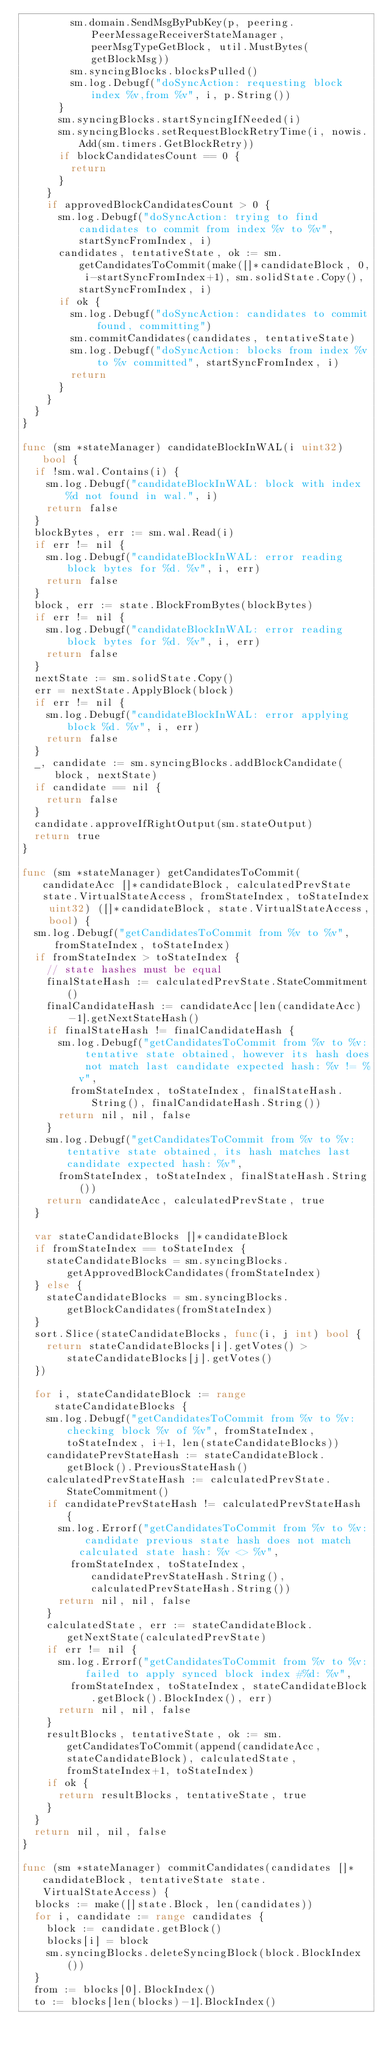<code> <loc_0><loc_0><loc_500><loc_500><_Go_>				sm.domain.SendMsgByPubKey(p, peering.PeerMessageReceiverStateManager, peerMsgTypeGetBlock, util.MustBytes(getBlockMsg))
				sm.syncingBlocks.blocksPulled()
				sm.log.Debugf("doSyncAction: requesting block index %v,from %v", i, p.String())
			}
			sm.syncingBlocks.startSyncingIfNeeded(i)
			sm.syncingBlocks.setRequestBlockRetryTime(i, nowis.Add(sm.timers.GetBlockRetry))
			if blockCandidatesCount == 0 {
				return
			}
		}
		if approvedBlockCandidatesCount > 0 {
			sm.log.Debugf("doSyncAction: trying to find candidates to commit from index %v to %v", startSyncFromIndex, i)
			candidates, tentativeState, ok := sm.getCandidatesToCommit(make([]*candidateBlock, 0, i-startSyncFromIndex+1), sm.solidState.Copy(), startSyncFromIndex, i)
			if ok {
				sm.log.Debugf("doSyncAction: candidates to commit found, committing")
				sm.commitCandidates(candidates, tentativeState)
				sm.log.Debugf("doSyncAction: blocks from index %v to %v committed", startSyncFromIndex, i)
				return
			}
		}
	}
}

func (sm *stateManager) candidateBlockInWAL(i uint32) bool {
	if !sm.wal.Contains(i) {
		sm.log.Debugf("candidateBlockInWAL: block with index %d not found in wal.", i)
		return false
	}
	blockBytes, err := sm.wal.Read(i)
	if err != nil {
		sm.log.Debugf("candidateBlockInWAL: error reading block bytes for %d. %v", i, err)
		return false
	}
	block, err := state.BlockFromBytes(blockBytes)
	if err != nil {
		sm.log.Debugf("candidateBlockInWAL: error reading block bytes for %d. %v", i, err)
		return false
	}
	nextState := sm.solidState.Copy()
	err = nextState.ApplyBlock(block)
	if err != nil {
		sm.log.Debugf("candidateBlockInWAL: error applying block %d. %v", i, err)
		return false
	}
	_, candidate := sm.syncingBlocks.addBlockCandidate(block, nextState)
	if candidate == nil {
		return false
	}
	candidate.approveIfRightOutput(sm.stateOutput)
	return true
}

func (sm *stateManager) getCandidatesToCommit(candidateAcc []*candidateBlock, calculatedPrevState state.VirtualStateAccess, fromStateIndex, toStateIndex uint32) ([]*candidateBlock, state.VirtualStateAccess, bool) {
	sm.log.Debugf("getCandidatesToCommit from %v to %v", fromStateIndex, toStateIndex)
	if fromStateIndex > toStateIndex {
		// state hashes must be equal
		finalStateHash := calculatedPrevState.StateCommitment()
		finalCandidateHash := candidateAcc[len(candidateAcc)-1].getNextStateHash()
		if finalStateHash != finalCandidateHash {
			sm.log.Debugf("getCandidatesToCommit from %v to %v: tentative state obtained, however its hash does not match last candidate expected hash: %v != %v",
				fromStateIndex, toStateIndex, finalStateHash.String(), finalCandidateHash.String())
			return nil, nil, false
		}
		sm.log.Debugf("getCandidatesToCommit from %v to %v: tentative state obtained, its hash matches last candidate expected hash: %v",
			fromStateIndex, toStateIndex, finalStateHash.String())
		return candidateAcc, calculatedPrevState, true
	}

	var stateCandidateBlocks []*candidateBlock
	if fromStateIndex == toStateIndex {
		stateCandidateBlocks = sm.syncingBlocks.getApprovedBlockCandidates(fromStateIndex)
	} else {
		stateCandidateBlocks = sm.syncingBlocks.getBlockCandidates(fromStateIndex)
	}
	sort.Slice(stateCandidateBlocks, func(i, j int) bool {
		return stateCandidateBlocks[i].getVotes() > stateCandidateBlocks[j].getVotes()
	})

	for i, stateCandidateBlock := range stateCandidateBlocks {
		sm.log.Debugf("getCandidatesToCommit from %v to %v: checking block %v of %v", fromStateIndex, toStateIndex, i+1, len(stateCandidateBlocks))
		candidatePrevStateHash := stateCandidateBlock.getBlock().PreviousStateHash()
		calculatedPrevStateHash := calculatedPrevState.StateCommitment()
		if candidatePrevStateHash != calculatedPrevStateHash {
			sm.log.Errorf("getCandidatesToCommit from %v to %v: candidate previous state hash does not match calculated state hash: %v <> %v",
				fromStateIndex, toStateIndex, candidatePrevStateHash.String(), calculatedPrevStateHash.String())
			return nil, nil, false
		}
		calculatedState, err := stateCandidateBlock.getNextState(calculatedPrevState)
		if err != nil {
			sm.log.Errorf("getCandidatesToCommit from %v to %v: failed to apply synced block index #%d: %v",
				fromStateIndex, toStateIndex, stateCandidateBlock.getBlock().BlockIndex(), err)
			return nil, nil, false
		}
		resultBlocks, tentativeState, ok := sm.getCandidatesToCommit(append(candidateAcc, stateCandidateBlock), calculatedState, fromStateIndex+1, toStateIndex)
		if ok {
			return resultBlocks, tentativeState, true
		}
	}
	return nil, nil, false
}

func (sm *stateManager) commitCandidates(candidates []*candidateBlock, tentativeState state.VirtualStateAccess) {
	blocks := make([]state.Block, len(candidates))
	for i, candidate := range candidates {
		block := candidate.getBlock()
		blocks[i] = block
		sm.syncingBlocks.deleteSyncingBlock(block.BlockIndex())
	}
	from := blocks[0].BlockIndex()
	to := blocks[len(blocks)-1].BlockIndex()</code> 